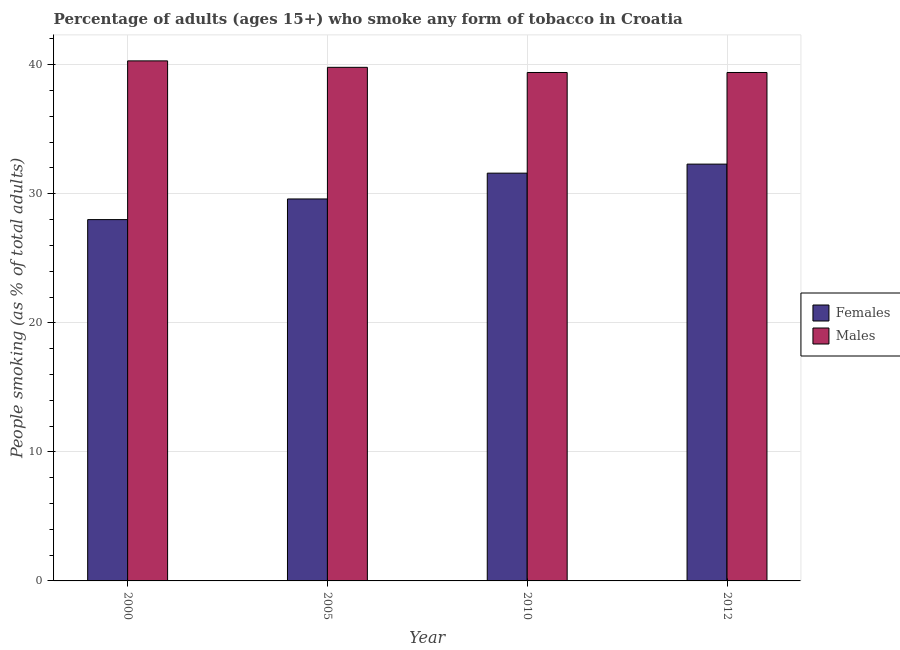How many groups of bars are there?
Offer a terse response. 4. Are the number of bars per tick equal to the number of legend labels?
Offer a very short reply. Yes. How many bars are there on the 4th tick from the right?
Provide a succinct answer. 2. What is the label of the 4th group of bars from the left?
Your response must be concise. 2012. In how many cases, is the number of bars for a given year not equal to the number of legend labels?
Keep it short and to the point. 0. What is the percentage of females who smoke in 2012?
Give a very brief answer. 32.3. Across all years, what is the maximum percentage of females who smoke?
Your answer should be compact. 32.3. Across all years, what is the minimum percentage of females who smoke?
Your answer should be very brief. 28. In which year was the percentage of females who smoke maximum?
Your answer should be very brief. 2012. In which year was the percentage of males who smoke minimum?
Keep it short and to the point. 2010. What is the total percentage of males who smoke in the graph?
Your response must be concise. 158.9. What is the difference between the percentage of females who smoke in 2000 and that in 2012?
Offer a terse response. -4.3. What is the average percentage of males who smoke per year?
Keep it short and to the point. 39.73. In the year 2012, what is the difference between the percentage of females who smoke and percentage of males who smoke?
Your answer should be compact. 0. In how many years, is the percentage of males who smoke greater than 4 %?
Make the answer very short. 4. What is the ratio of the percentage of males who smoke in 2010 to that in 2012?
Offer a very short reply. 1. What is the difference between the highest and the second highest percentage of males who smoke?
Your answer should be compact. 0.5. What is the difference between the highest and the lowest percentage of males who smoke?
Offer a very short reply. 0.9. In how many years, is the percentage of females who smoke greater than the average percentage of females who smoke taken over all years?
Keep it short and to the point. 2. Is the sum of the percentage of females who smoke in 2000 and 2010 greater than the maximum percentage of males who smoke across all years?
Ensure brevity in your answer.  Yes. What does the 2nd bar from the left in 2000 represents?
Give a very brief answer. Males. What does the 1st bar from the right in 2000 represents?
Give a very brief answer. Males. How many bars are there?
Your response must be concise. 8. Are all the bars in the graph horizontal?
Your response must be concise. No. Are the values on the major ticks of Y-axis written in scientific E-notation?
Your response must be concise. No. Does the graph contain any zero values?
Provide a succinct answer. No. Does the graph contain grids?
Keep it short and to the point. Yes. What is the title of the graph?
Make the answer very short. Percentage of adults (ages 15+) who smoke any form of tobacco in Croatia. What is the label or title of the X-axis?
Offer a terse response. Year. What is the label or title of the Y-axis?
Your response must be concise. People smoking (as % of total adults). What is the People smoking (as % of total adults) of Males in 2000?
Offer a terse response. 40.3. What is the People smoking (as % of total adults) in Females in 2005?
Keep it short and to the point. 29.6. What is the People smoking (as % of total adults) of Males in 2005?
Offer a terse response. 39.8. What is the People smoking (as % of total adults) of Females in 2010?
Your answer should be very brief. 31.6. What is the People smoking (as % of total adults) of Males in 2010?
Make the answer very short. 39.4. What is the People smoking (as % of total adults) in Females in 2012?
Provide a short and direct response. 32.3. What is the People smoking (as % of total adults) of Males in 2012?
Ensure brevity in your answer.  39.4. Across all years, what is the maximum People smoking (as % of total adults) in Females?
Give a very brief answer. 32.3. Across all years, what is the maximum People smoking (as % of total adults) in Males?
Ensure brevity in your answer.  40.3. Across all years, what is the minimum People smoking (as % of total adults) in Females?
Offer a terse response. 28. Across all years, what is the minimum People smoking (as % of total adults) in Males?
Your answer should be compact. 39.4. What is the total People smoking (as % of total adults) of Females in the graph?
Keep it short and to the point. 121.5. What is the total People smoking (as % of total adults) in Males in the graph?
Give a very brief answer. 158.9. What is the difference between the People smoking (as % of total adults) of Females in 2000 and that in 2005?
Keep it short and to the point. -1.6. What is the difference between the People smoking (as % of total adults) in Males in 2000 and that in 2005?
Make the answer very short. 0.5. What is the difference between the People smoking (as % of total adults) of Females in 2000 and that in 2010?
Provide a succinct answer. -3.6. What is the difference between the People smoking (as % of total adults) in Males in 2000 and that in 2010?
Offer a terse response. 0.9. What is the difference between the People smoking (as % of total adults) of Males in 2000 and that in 2012?
Make the answer very short. 0.9. What is the difference between the People smoking (as % of total adults) of Females in 2005 and that in 2010?
Offer a very short reply. -2. What is the difference between the People smoking (as % of total adults) in Males in 2005 and that in 2012?
Make the answer very short. 0.4. What is the difference between the People smoking (as % of total adults) of Females in 2010 and that in 2012?
Provide a short and direct response. -0.7. What is the difference between the People smoking (as % of total adults) of Males in 2010 and that in 2012?
Offer a very short reply. 0. What is the difference between the People smoking (as % of total adults) of Females in 2005 and the People smoking (as % of total adults) of Males in 2010?
Give a very brief answer. -9.8. What is the difference between the People smoking (as % of total adults) in Females in 2010 and the People smoking (as % of total adults) in Males in 2012?
Your answer should be compact. -7.8. What is the average People smoking (as % of total adults) of Females per year?
Provide a succinct answer. 30.38. What is the average People smoking (as % of total adults) of Males per year?
Your answer should be compact. 39.73. What is the ratio of the People smoking (as % of total adults) of Females in 2000 to that in 2005?
Provide a short and direct response. 0.95. What is the ratio of the People smoking (as % of total adults) of Males in 2000 to that in 2005?
Ensure brevity in your answer.  1.01. What is the ratio of the People smoking (as % of total adults) in Females in 2000 to that in 2010?
Keep it short and to the point. 0.89. What is the ratio of the People smoking (as % of total adults) in Males in 2000 to that in 2010?
Keep it short and to the point. 1.02. What is the ratio of the People smoking (as % of total adults) in Females in 2000 to that in 2012?
Keep it short and to the point. 0.87. What is the ratio of the People smoking (as % of total adults) in Males in 2000 to that in 2012?
Keep it short and to the point. 1.02. What is the ratio of the People smoking (as % of total adults) in Females in 2005 to that in 2010?
Give a very brief answer. 0.94. What is the ratio of the People smoking (as % of total adults) in Males in 2005 to that in 2010?
Keep it short and to the point. 1.01. What is the ratio of the People smoking (as % of total adults) of Females in 2005 to that in 2012?
Your answer should be compact. 0.92. What is the ratio of the People smoking (as % of total adults) in Males in 2005 to that in 2012?
Offer a very short reply. 1.01. What is the ratio of the People smoking (as % of total adults) in Females in 2010 to that in 2012?
Provide a succinct answer. 0.98. What is the difference between the highest and the second highest People smoking (as % of total adults) in Females?
Make the answer very short. 0.7. What is the difference between the highest and the second highest People smoking (as % of total adults) of Males?
Provide a short and direct response. 0.5. What is the difference between the highest and the lowest People smoking (as % of total adults) in Males?
Offer a very short reply. 0.9. 